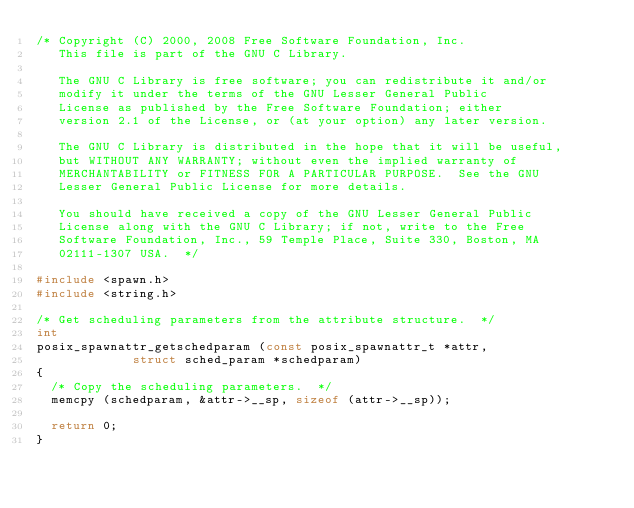Convert code to text. <code><loc_0><loc_0><loc_500><loc_500><_C_>/* Copyright (C) 2000, 2008 Free Software Foundation, Inc.
   This file is part of the GNU C Library.

   The GNU C Library is free software; you can redistribute it and/or
   modify it under the terms of the GNU Lesser General Public
   License as published by the Free Software Foundation; either
   version 2.1 of the License, or (at your option) any later version.

   The GNU C Library is distributed in the hope that it will be useful,
   but WITHOUT ANY WARRANTY; without even the implied warranty of
   MERCHANTABILITY or FITNESS FOR A PARTICULAR PURPOSE.  See the GNU
   Lesser General Public License for more details.

   You should have received a copy of the GNU Lesser General Public
   License along with the GNU C Library; if not, write to the Free
   Software Foundation, Inc., 59 Temple Place, Suite 330, Boston, MA
   02111-1307 USA.  */

#include <spawn.h>
#include <string.h>

/* Get scheduling parameters from the attribute structure.  */
int
posix_spawnattr_getschedparam (const posix_spawnattr_t *attr,
			       struct sched_param *schedparam)
{
  /* Copy the scheduling parameters.  */
  memcpy (schedparam, &attr->__sp, sizeof (attr->__sp));

  return 0;
}
</code> 